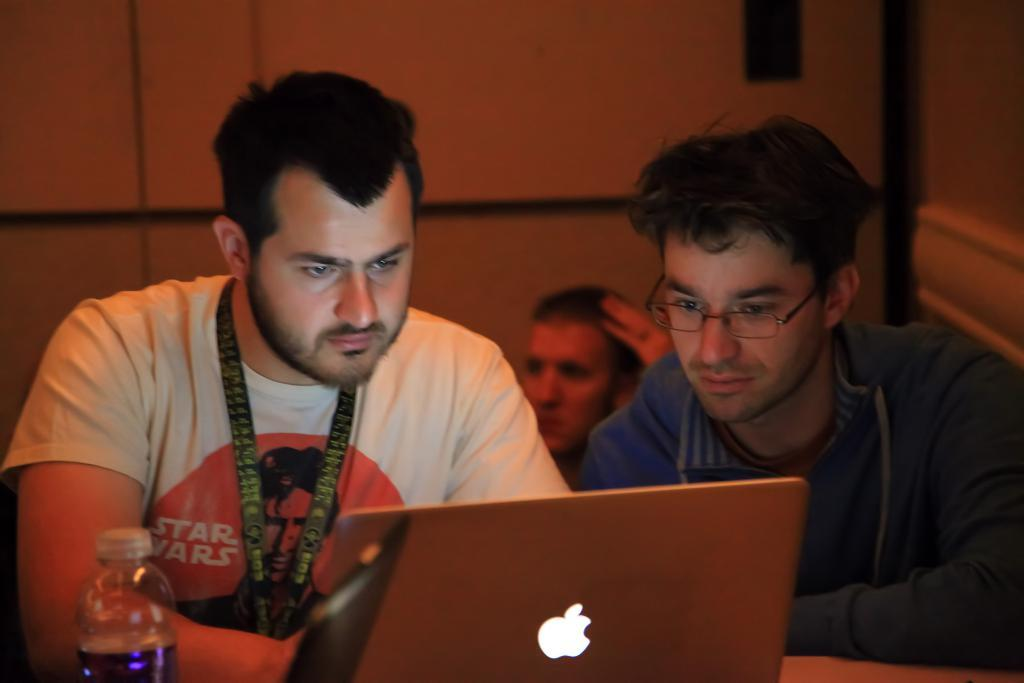How many people are present in the image? There are three people in the image. What are some of the people doing in the image? Some people are looking at a laptop. Are there any other laptops visible in the image? Yes, there is another laptop at the bottom of the image. What other object can be seen in the image? There is a bottle in the image. What can be seen in the background of the image? There is a wall visible in the background of the image. What type of flag is being waved by the person in the image? There is no flag present in the image; it only features three people, laptops, a bottle, and a wall in the background. What kind of boot is being worn by the person in the image? There is no information about footwear in the image, as it focuses on people, laptops, a bottle, and a wall in the background. 